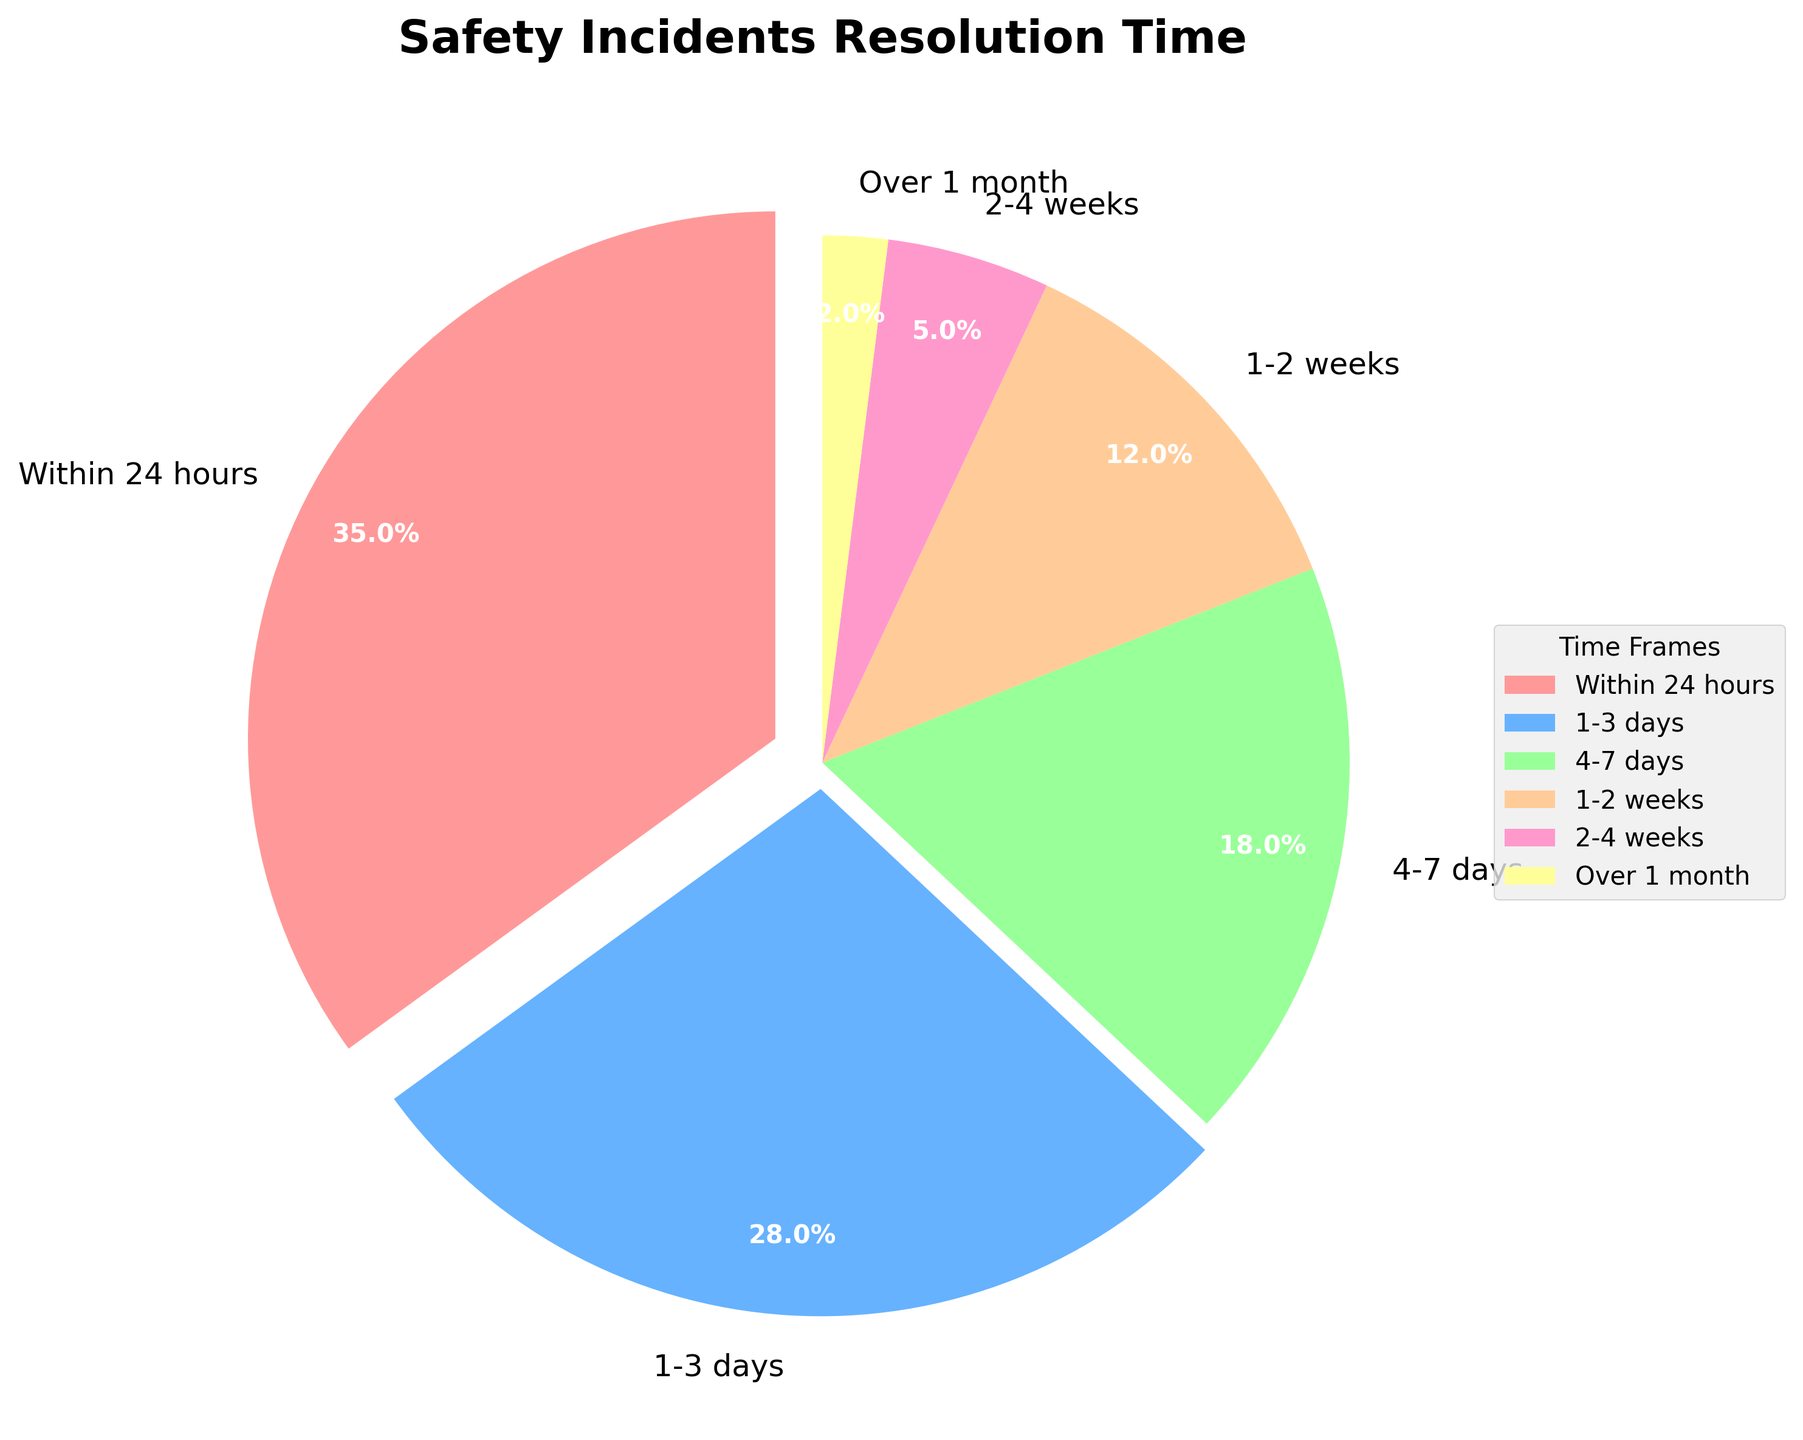Which time frame resolves the highest percentage of safety incidents? The chart shows the largest slice of the pie chart corresponds to the "Within 24 hours" time frame.
Answer: Within 24 hours What percentage of incidents are resolved in under a week? Add the percentages of incidents resolved "Within 24 hours", "1-3 days", and "4-7 days". \(35 + 28 + 18 = 81\)
Answer: 81% Is the percentage of incidents resolved in 1-3 days greater than those resolved in 4-7 days? Compare the percentages directly from the chart. "1-3 days" is 28%, and "4-7 days" is 18%. 28% > 18%
Answer: Yes What is the combined percentage of incidents resolved within a month? Add the percentages for "Within 24 hours", "1-3 days", "4-7 days", "1-2 weeks", and "2-4 weeks". \(35 + 28 + 18 + 12 + 5 = 98\)
Answer: 98% Which color represents the "2-4 weeks" time frame? Referencing the legend or the slices' colors, the "2-4 weeks" time frame corresponds to the bright yellow color.
Answer: Yellow How does the percentage of incidents resolved in "1-2 weeks" compare to those resolved in "Over 1 month"? Compare the percentages directly: "1-2 weeks" is 12%, and “Over 1 month” is 2%. 12% > 2%
Answer: 1-2 weeks has a higher percentage What is the difference in percentage between incidents resolved within 24 hours and those resolved in over 1 month? Subtract the percentage of "Over 1 month" from "Within 24 hours": \(35 - 2 = 33\)
Answer: 33% What percentage of incidents are resolved taking more than a week? Add percentages of "1-2 weeks", "2-4 weeks", and "Over 1 month". \(12 + 5 + 2 = 19\)
Answer: 19% Which time frame holds the smallest percentage? The chart shows the smallest slice which corresponds to "Over 1 month" time frame.
Answer: Over 1 month How much higher is the percentage of incidents resolved within 24 hours compared to those resolved in 1-3 days? Subtract the percentage of incidents resolved in 1-3 days from those resolved within 24 hours: \(35 - 28 = 7\)
Answer: 7% 